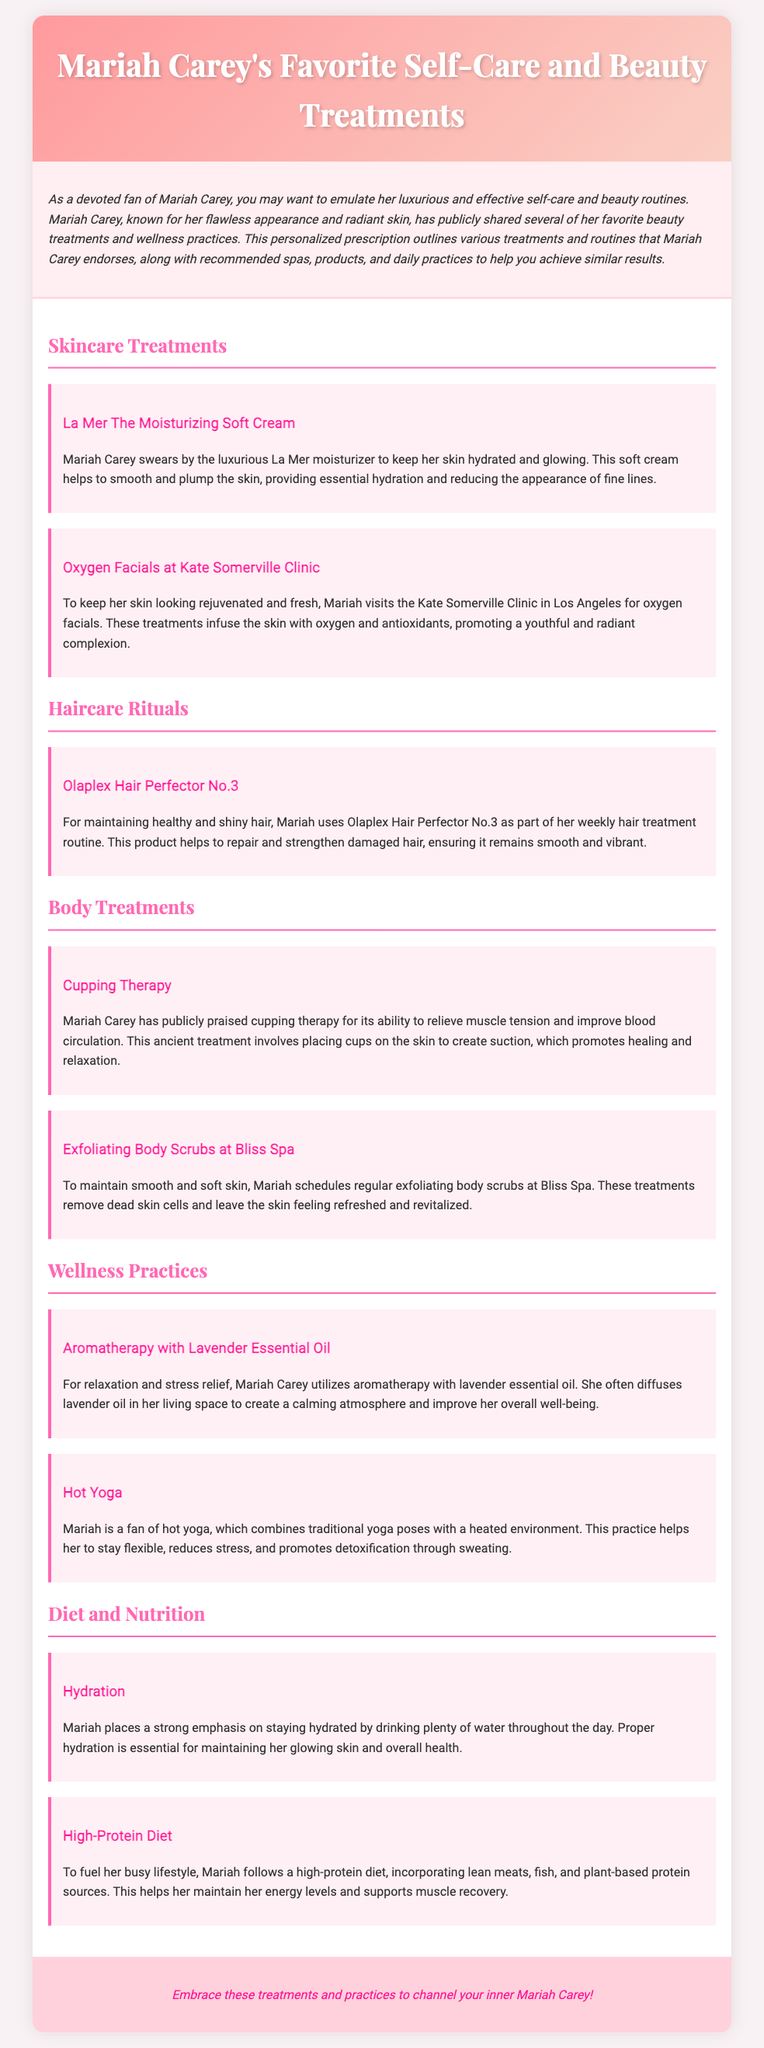What moisturizer does Mariah Carey use? The document states that Mariah Carey swears by La Mer The Moisturizing Soft Cream to keep her skin hydrated and glowing.
Answer: La Mer The Moisturizing Soft Cream Where does Mariah receive oxygen facials? According to the document, Mariah visits the Kate Somerville Clinic in Los Angeles for oxygen facials.
Answer: Kate Somerville Clinic What hair treatment product does Mariah use weekly? The document mentions that Mariah uses Olaplex Hair Perfector No.3 as part of her weekly hair treatment routine.
Answer: Olaplex Hair Perfector No.3 What type of body treatment does Mariah utilize for muscle tension? Mariah Carey has publicly praised cupping therapy for its ability to relieve muscle tension and improve blood circulation.
Answer: Cupping Therapy Which essential oil does Mariah use for aromatherapy? The document states that Mariah utilizes aromatherapy with lavender essential oil for relaxation and stress relief.
Answer: Lavender essential oil What is a key aspect of Mariah's diet? Mariah emphasizes staying hydrated by drinking plenty of water throughout the day for maintaining her glowing skin and overall health.
Answer: Hydration What yoga practice does Mariah enjoy? The document indicates that Mariah is a fan of hot yoga, which combines traditional yoga poses with a heated environment.
Answer: Hot Yoga Which spa does Mariah frequent for body scrubs? Mariah schedules regular exfoliating body scrubs at Bliss Spa to maintain smooth and soft skin.
Answer: Bliss Spa 